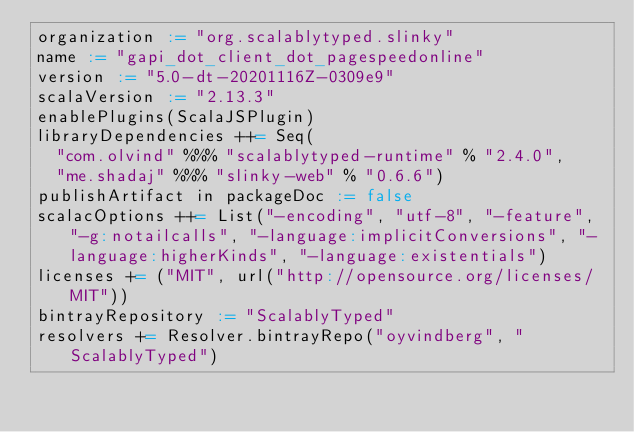Convert code to text. <code><loc_0><loc_0><loc_500><loc_500><_Scala_>organization := "org.scalablytyped.slinky"
name := "gapi_dot_client_dot_pagespeedonline"
version := "5.0-dt-20201116Z-0309e9"
scalaVersion := "2.13.3"
enablePlugins(ScalaJSPlugin)
libraryDependencies ++= Seq(
  "com.olvind" %%% "scalablytyped-runtime" % "2.4.0",
  "me.shadaj" %%% "slinky-web" % "0.6.6")
publishArtifact in packageDoc := false
scalacOptions ++= List("-encoding", "utf-8", "-feature", "-g:notailcalls", "-language:implicitConversions", "-language:higherKinds", "-language:existentials")
licenses += ("MIT", url("http://opensource.org/licenses/MIT"))
bintrayRepository := "ScalablyTyped"
resolvers += Resolver.bintrayRepo("oyvindberg", "ScalablyTyped")
</code> 